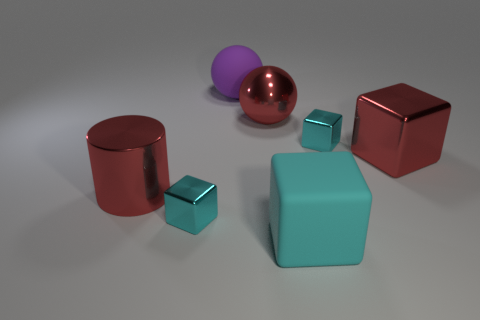How many objects are cubes that are behind the cyan matte object or big red cubes?
Ensure brevity in your answer.  3. There is a big ball that is the same material as the cylinder; what color is it?
Your answer should be compact. Red. Are there any objects that have the same size as the shiny sphere?
Keep it short and to the point. Yes. What number of objects are red metallic things left of the big purple ball or red shiny objects that are in front of the matte ball?
Offer a very short reply. 3. What is the shape of the purple thing that is the same size as the red metallic cube?
Provide a short and direct response. Sphere. Is there a cyan shiny thing of the same shape as the cyan rubber thing?
Provide a short and direct response. Yes. Are there fewer cyan rubber objects than big purple metal blocks?
Provide a short and direct response. No. Do the metal block in front of the cylinder and the red object behind the big metal cube have the same size?
Your answer should be compact. No. How many objects are either cyan objects or large red matte balls?
Keep it short and to the point. 3. How big is the cyan block behind the large red cube?
Make the answer very short. Small. 